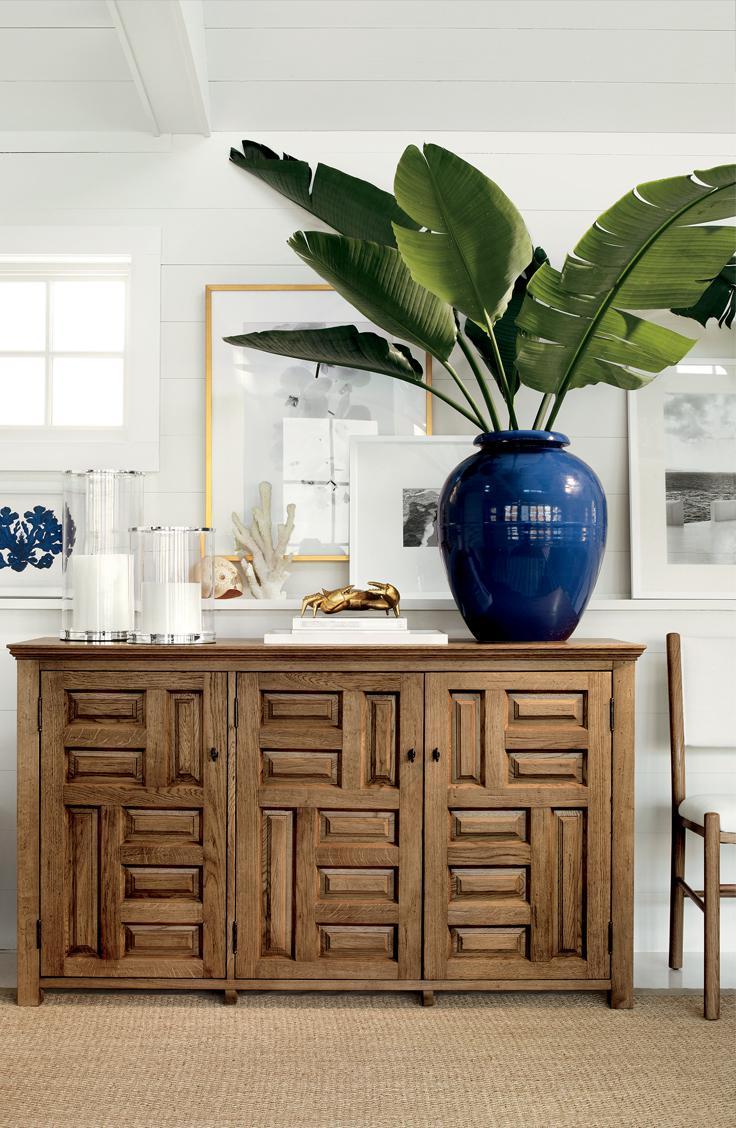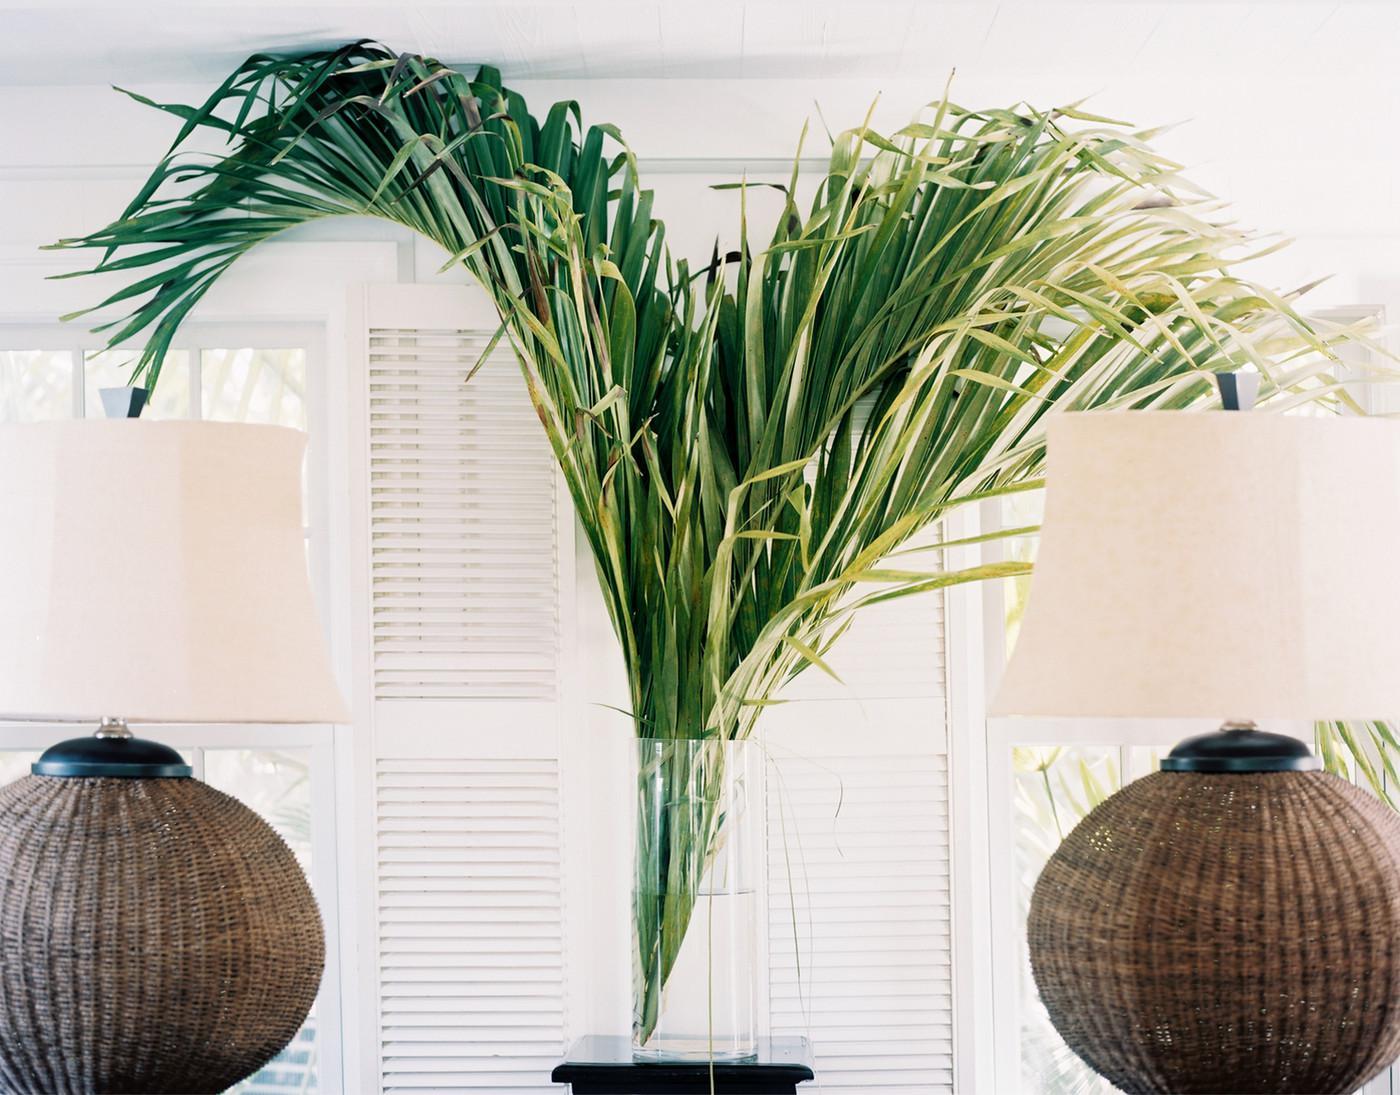The first image is the image on the left, the second image is the image on the right. Examine the images to the left and right. Is the description "The right image features a palm frond in a clear cylindrical vase flanked by objects with matching shapes." accurate? Answer yes or no. Yes. The first image is the image on the left, the second image is the image on the right. For the images shown, is this caption "The left and right image contains the same number of palm leaves." true? Answer yes or no. No. 